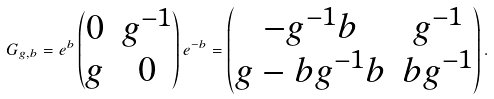<formula> <loc_0><loc_0><loc_500><loc_500>G _ { g , b } = e ^ { b } \begin{pmatrix} 0 & g ^ { - 1 } \\ g & 0 \end{pmatrix} e ^ { - b } = \begin{pmatrix} - g ^ { - 1 } b & g ^ { - 1 } \\ g - b g ^ { - 1 } b & b g ^ { - 1 } \end{pmatrix} .</formula> 